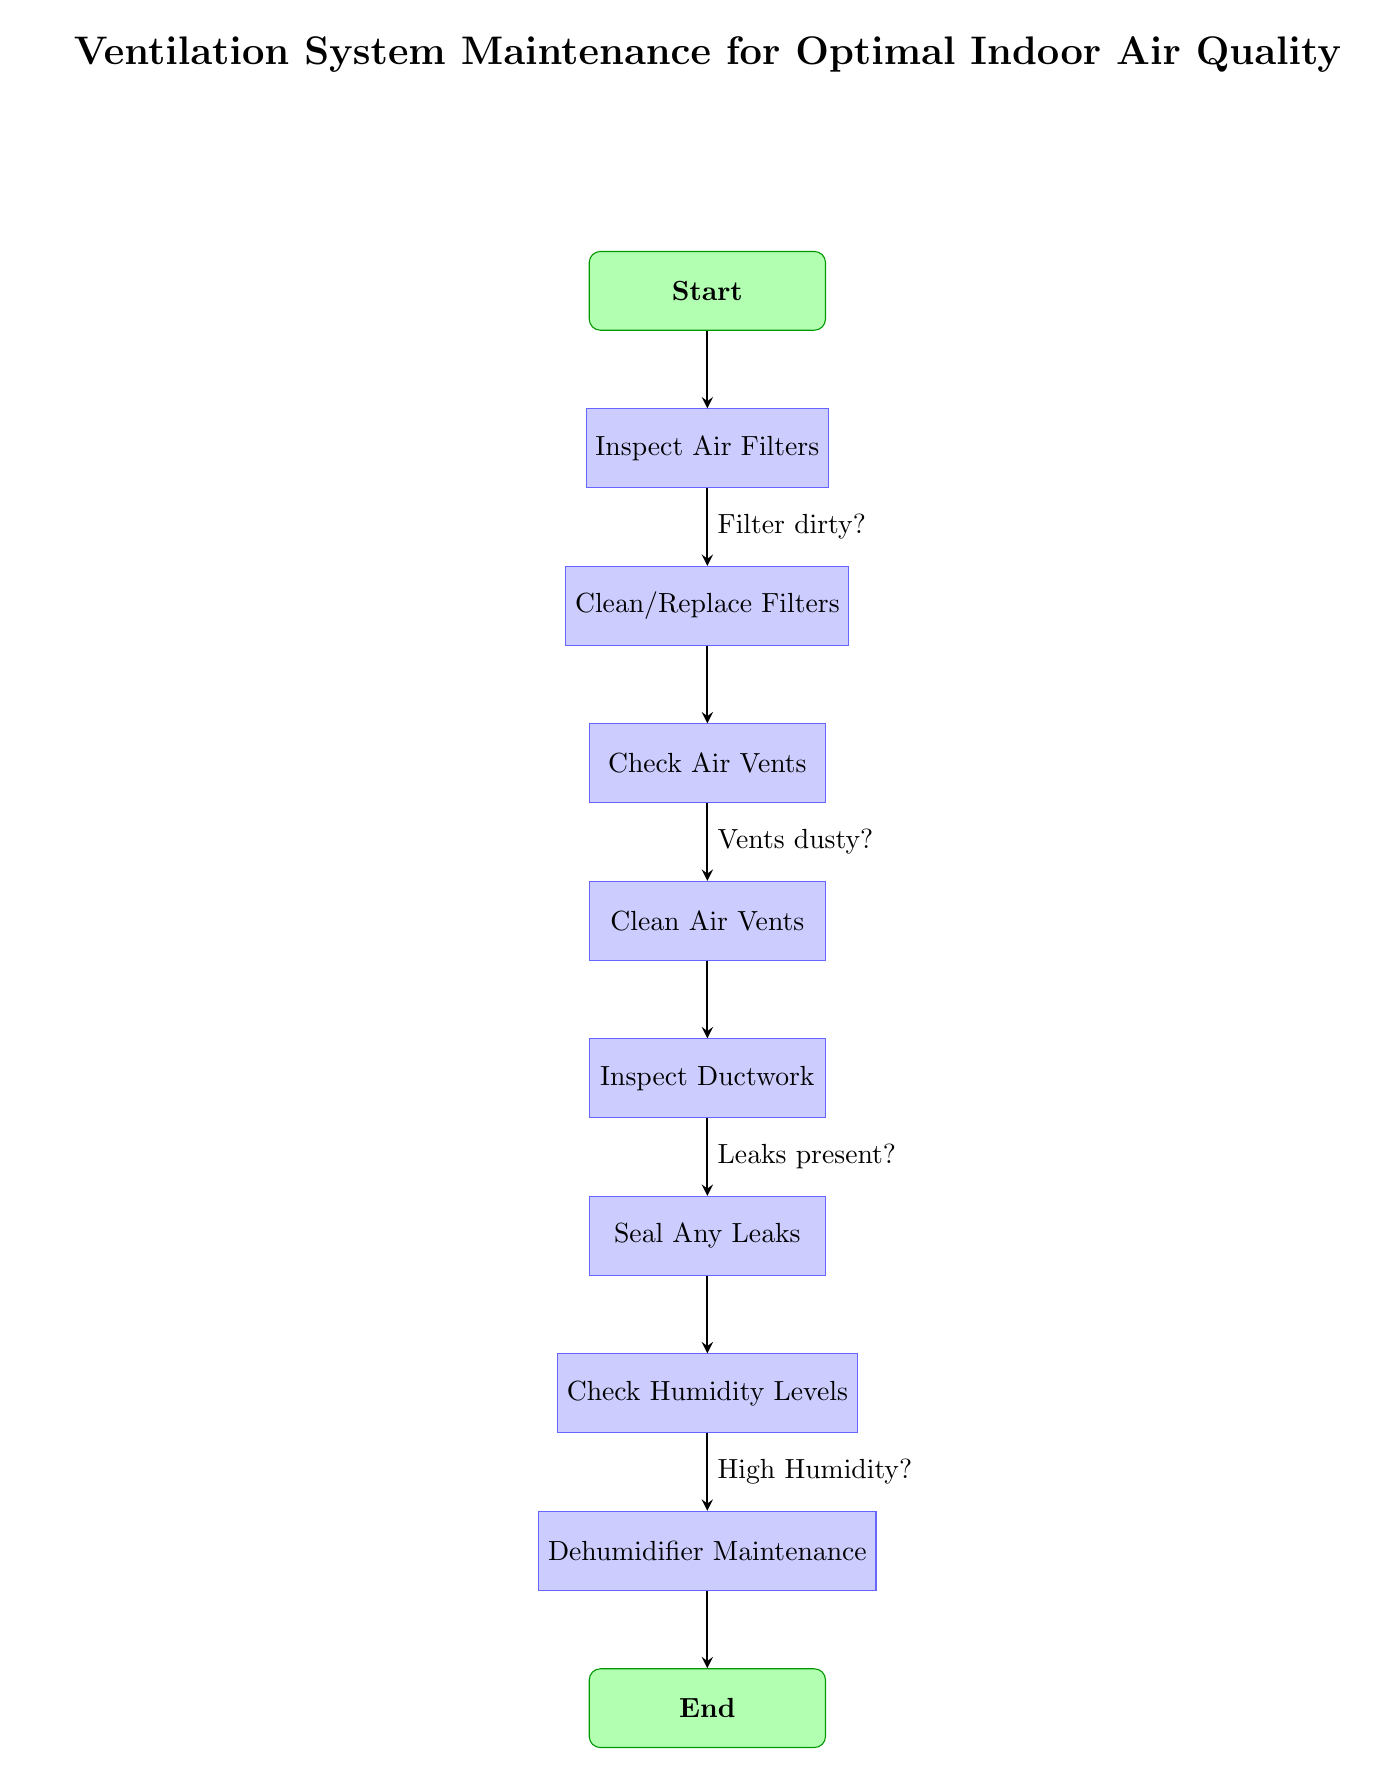What is the title of the diagram? The title is positioned above the "Start" node and mentions the purpose of the flowchart which is "Ventilation System Maintenance for Optimal Indoor Air Quality".
Answer: Ventilation System Maintenance for Optimal Indoor Air Quality How many process nodes are there? There are a total of 7 process nodes in the diagram: "Inspect Air Filters", "Clean/Replace Filters", "Check Air Vents", "Clean Air Vents", "Inspect Ductwork", "Seal Any Leaks", and "Check Humidity Levels".
Answer: 7 What is the first step in the maintenance process? The first node directly connected after "Start" is "Inspect Air Filters", which indicates the beginning of the maintenance process.
Answer: Inspect Air Filters What decision is made after inspecting air filters? After inspecting air filters, the decision made is whether the "Filter dirty?" which will determine if the next step is to "Clean/Replace Filters".
Answer: Filter dirty? What action follows after checking humidity levels? The last process node following "Check Humidity Levels" is "Dehumidifier Maintenance", as it addresses the maintenance required based on humidity conditions.
Answer: Dehumidifier Maintenance How many decision points are there in the diagram? The diagram contains 3 decision points: "Filter dirty?", "Vents dusty?", and "Leaks present?", each leading to decisions that influence the flow of the maintenance process.
Answer: 3 What action is taken if leaks are present? If leaks are present after inspecting ductwork, the maintenance process specifies to "Seal Any Leaks".
Answer: Seal Any Leaks What is the final step in the maintenance process? The final node in the flowchart sequence is "End", which signifies the conclusion of the maintenance routine after all processes and checks have been completed.
Answer: End 